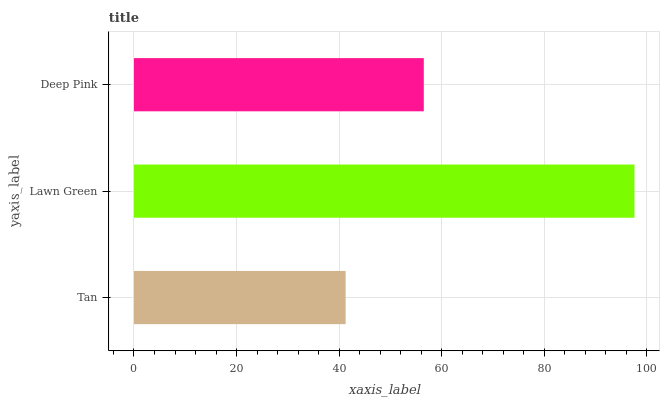Is Tan the minimum?
Answer yes or no. Yes. Is Lawn Green the maximum?
Answer yes or no. Yes. Is Deep Pink the minimum?
Answer yes or no. No. Is Deep Pink the maximum?
Answer yes or no. No. Is Lawn Green greater than Deep Pink?
Answer yes or no. Yes. Is Deep Pink less than Lawn Green?
Answer yes or no. Yes. Is Deep Pink greater than Lawn Green?
Answer yes or no. No. Is Lawn Green less than Deep Pink?
Answer yes or no. No. Is Deep Pink the high median?
Answer yes or no. Yes. Is Deep Pink the low median?
Answer yes or no. Yes. Is Tan the high median?
Answer yes or no. No. Is Tan the low median?
Answer yes or no. No. 